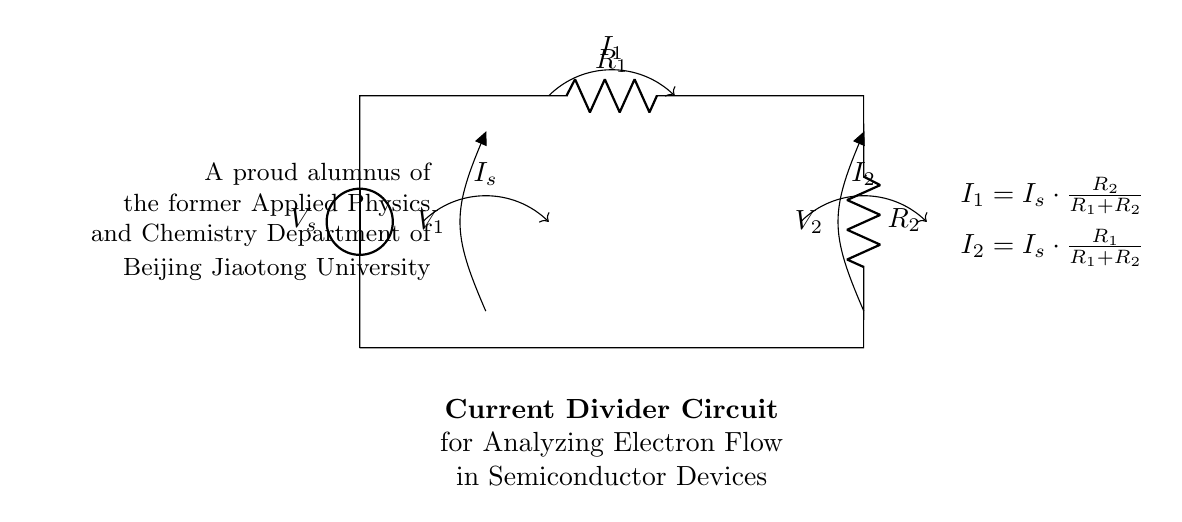What is the source voltage in this circuit? The source voltage is labeled as \( V_s \), which indicates the voltage provided to the circuit.
Answer: \( V_s \) What is the resistance value of \( R_1 \)? The resistance of \( R_1 \) is clearly indicated in the circuit diagram, but the specific numerical value is not provided; it's shown as a variable.
Answer: \( R_1 \) What is the expression for current \( I_1 \)? The expression for current \( I_1 \) can be derived from the current divider rule, which states that \( I_1 = I_s \cdot \frac{R_2}{R_1 + R_2} \); this is listed next to the circuit.
Answer: \( I_s \cdot \frac{R_2}{R_1 + R_2} \) How does the current \( I_2 \) relate to \( I_s \)? The relationship between \( I_2 \) and \( I_s \) can be understood through the current divider rule, which states that \( I_2 = I_s \cdot \frac{R_1}{R_1 + R_2} \); this shows how \( I_2 \) depends on both resistances.
Answer: \( I_s \cdot \frac{R_1}{R_1 + R_2} \) What is the function of the current divider in this circuit? A current divider is used to distribute the input current \( I_s \) into two output currents \( I_1 \) and \( I_2 \) proportionally based on the resistances \( R_1 \) and \( R_2 \).
Answer: Distributing current If \( R_1 \) equals \( R_2 \), what can be said about \( I_1 \) and \( I_2 \)? If \( R_1 \) equals \( R_2 \), then the currents \( I_1 \) and \( I_2 \) are equal because they are each half of the input current \( I_s \). This follows from the current divider rule previously mentioned.
Answer: \( I_1 = I_2 \) 